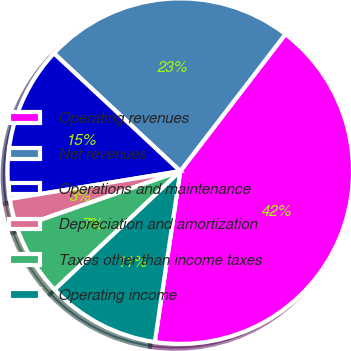Convert chart. <chart><loc_0><loc_0><loc_500><loc_500><pie_chart><fcel>Operating revenues<fcel>Net revenues<fcel>Operations and maintenance<fcel>Depreciation and amortization<fcel>Taxes other than income taxes<fcel>Operating income<nl><fcel>41.94%<fcel>23.47%<fcel>14.52%<fcel>2.77%<fcel>6.69%<fcel>10.61%<nl></chart> 